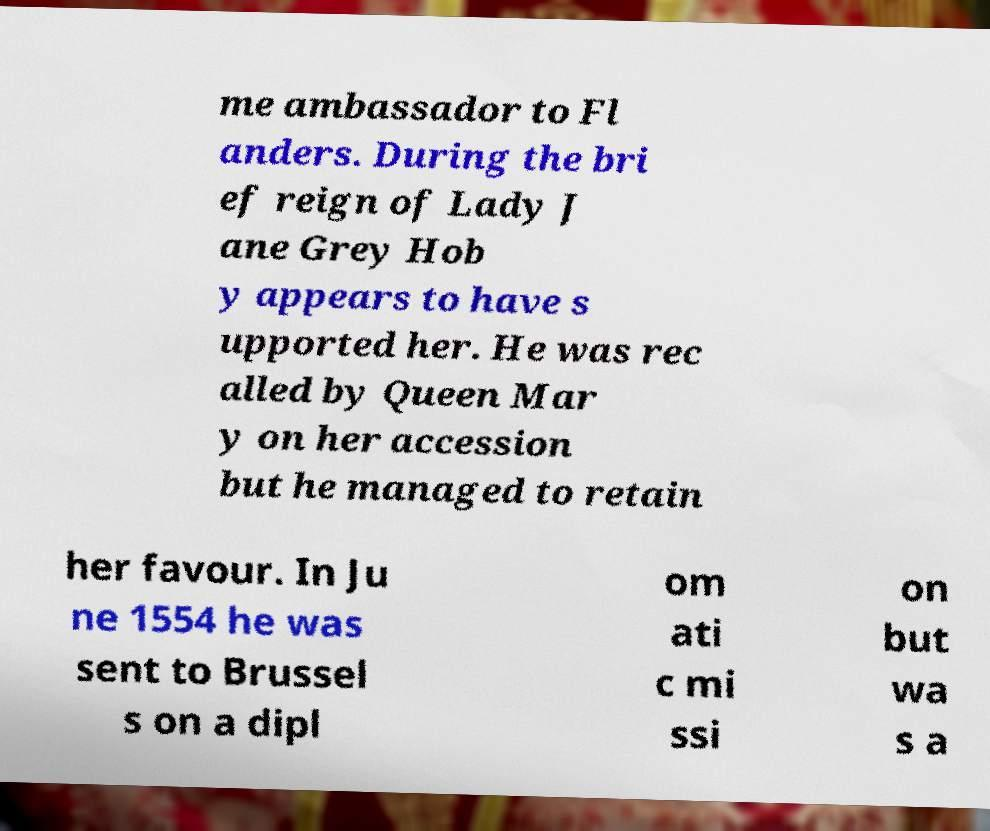For documentation purposes, I need the text within this image transcribed. Could you provide that? me ambassador to Fl anders. During the bri ef reign of Lady J ane Grey Hob y appears to have s upported her. He was rec alled by Queen Mar y on her accession but he managed to retain her favour. In Ju ne 1554 he was sent to Brussel s on a dipl om ati c mi ssi on but wa s a 